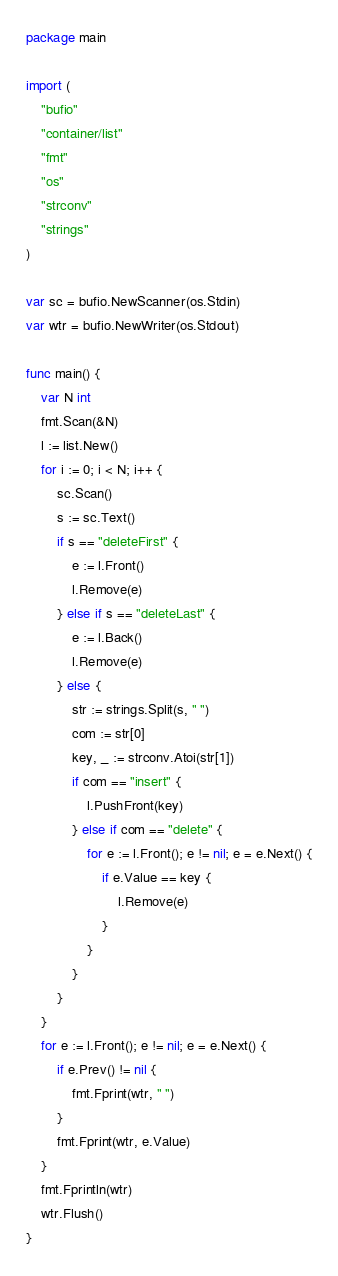Convert code to text. <code><loc_0><loc_0><loc_500><loc_500><_Go_>package main

import (
	"bufio"
	"container/list"
	"fmt"
	"os"
	"strconv"
	"strings"
)

var sc = bufio.NewScanner(os.Stdin)
var wtr = bufio.NewWriter(os.Stdout)

func main() {
	var N int
	fmt.Scan(&N)
	l := list.New()
	for i := 0; i < N; i++ {
		sc.Scan()
		s := sc.Text()
		if s == "deleteFirst" {
			e := l.Front()
			l.Remove(e)
		} else if s == "deleteLast" {
			e := l.Back()
			l.Remove(e)
		} else {
			str := strings.Split(s, " ")
			com := str[0]
			key, _ := strconv.Atoi(str[1])
			if com == "insert" {
				l.PushFront(key)
			} else if com == "delete" {
				for e := l.Front(); e != nil; e = e.Next() {
					if e.Value == key {
						l.Remove(e)
					}
				}
			}
		}
	}
	for e := l.Front(); e != nil; e = e.Next() {
		if e.Prev() != nil {
			fmt.Fprint(wtr, " ")
		}
		fmt.Fprint(wtr, e.Value)
	}
	fmt.Fprintln(wtr)
	wtr.Flush()
}

</code> 